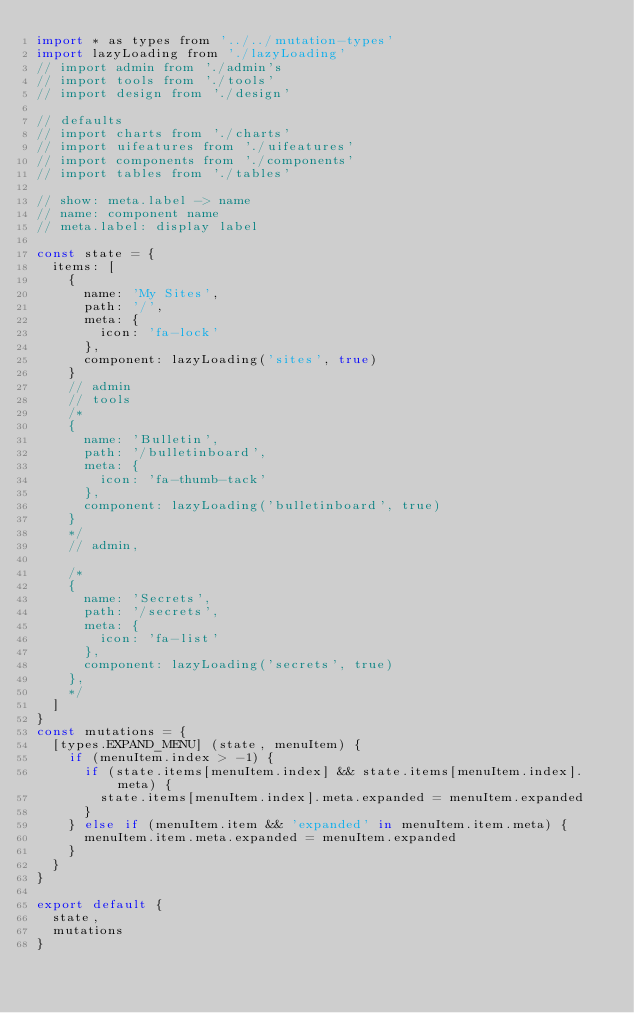<code> <loc_0><loc_0><loc_500><loc_500><_JavaScript_>import * as types from '../../mutation-types'
import lazyLoading from './lazyLoading'
// import admin from './admin's
// import tools from './tools'
// import design from './design'

// defaults
// import charts from './charts'
// import uifeatures from './uifeatures'
// import components from './components'
// import tables from './tables'

// show: meta.label -> name
// name: component name
// meta.label: display label

const state = {
  items: [
    {
      name: 'My Sites',
      path: '/',
      meta: {
        icon: 'fa-lock'
      },
      component: lazyLoading('sites', true)
    }
    // admin
    // tools
    /*
    {
      name: 'Bulletin',
      path: '/bulletinboard',
      meta: {
        icon: 'fa-thumb-tack'
      },
      component: lazyLoading('bulletinboard', true)
    }
    */
    // admin,

    /*
    {
      name: 'Secrets',
      path: '/secrets',
      meta: {
        icon: 'fa-list'
      },
      component: lazyLoading('secrets', true)
    },
    */
  ]
}
const mutations = {
  [types.EXPAND_MENU] (state, menuItem) {
    if (menuItem.index > -1) {
      if (state.items[menuItem.index] && state.items[menuItem.index].meta) {
        state.items[menuItem.index].meta.expanded = menuItem.expanded
      }
    } else if (menuItem.item && 'expanded' in menuItem.item.meta) {
      menuItem.item.meta.expanded = menuItem.expanded
    }
  }
}

export default {
  state,
  mutations
}
</code> 